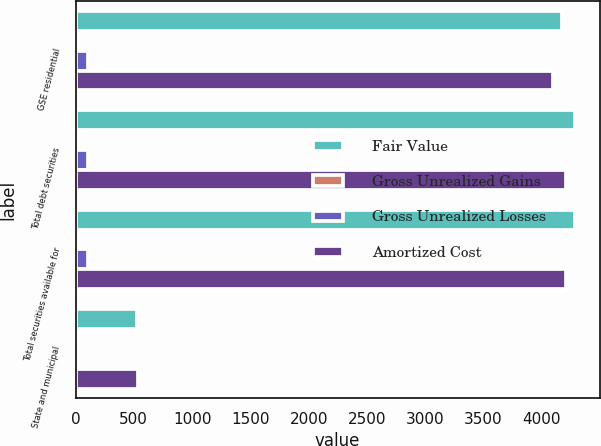Convert chart to OTSL. <chart><loc_0><loc_0><loc_500><loc_500><stacked_bar_chart><ecel><fcel>GSE residential<fcel>Total debt securities<fcel>Total securities available for<fcel>State and municipal<nl><fcel>Fair Value<fcel>4172.2<fcel>4281.7<fcel>4281.9<fcel>527.4<nl><fcel>Gross Unrealized Gains<fcel>30.6<fcel>32.8<fcel>32.8<fcel>15<nl><fcel>Gross Unrealized Losses<fcel>106.4<fcel>106.5<fcel>106.5<fcel>2.8<nl><fcel>Amortized Cost<fcel>4096.4<fcel>4208<fcel>4208.2<fcel>539.6<nl></chart> 